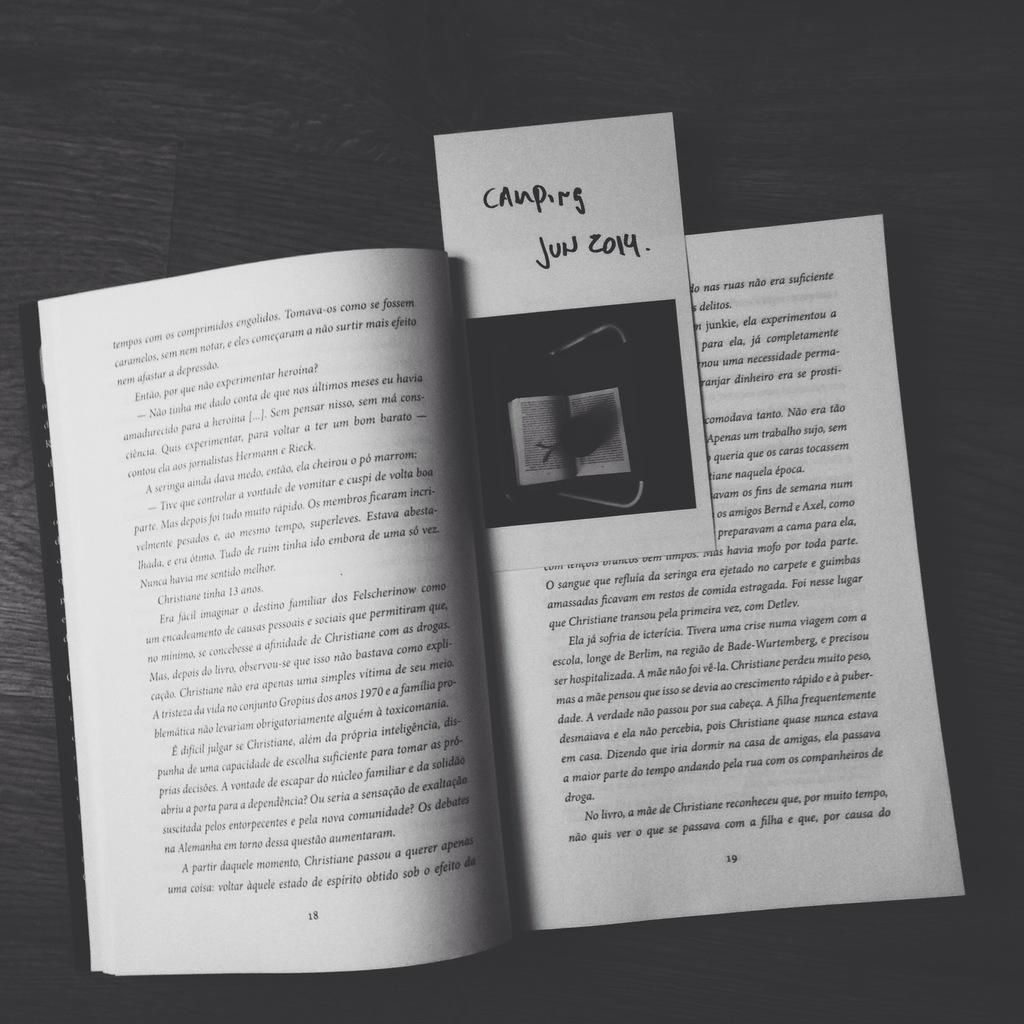What is the color scheme of the image? The image is black and white. What object can be seen in the image? There is a book in the image. Is there anything placed on the book? Yes, there is a paper on the book. Can you tell me how many seeds are visible in the image? There are no seeds present in the image. Is there a lake visible in the image? No, there is no lake visible in the image. 